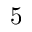Convert formula to latex. <formula><loc_0><loc_0><loc_500><loc_500>5</formula> 